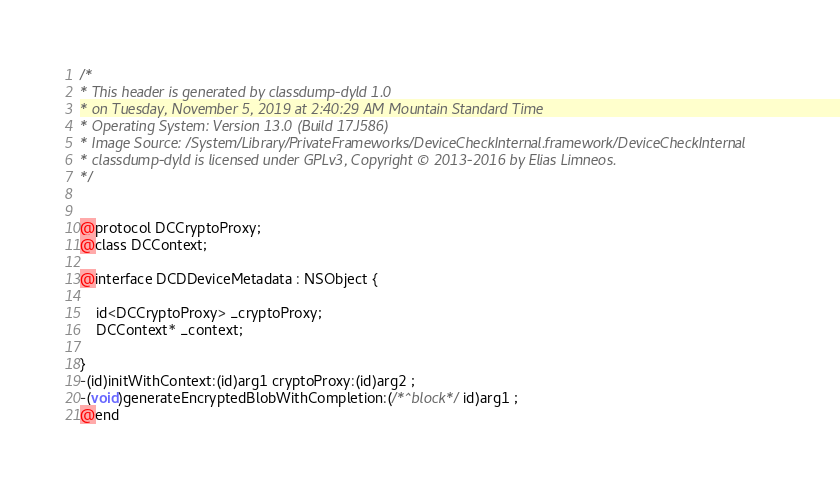<code> <loc_0><loc_0><loc_500><loc_500><_C_>/*
* This header is generated by classdump-dyld 1.0
* on Tuesday, November 5, 2019 at 2:40:29 AM Mountain Standard Time
* Operating System: Version 13.0 (Build 17J586)
* Image Source: /System/Library/PrivateFrameworks/DeviceCheckInternal.framework/DeviceCheckInternal
* classdump-dyld is licensed under GPLv3, Copyright © 2013-2016 by Elias Limneos.
*/


@protocol DCCryptoProxy;
@class DCContext;

@interface DCDDeviceMetadata : NSObject {

	id<DCCryptoProxy> _cryptoProxy;
	DCContext* _context;

}
-(id)initWithContext:(id)arg1 cryptoProxy:(id)arg2 ;
-(void)generateEncryptedBlobWithCompletion:(/*^block*/id)arg1 ;
@end

</code> 